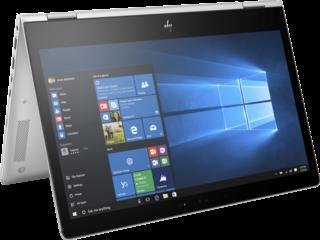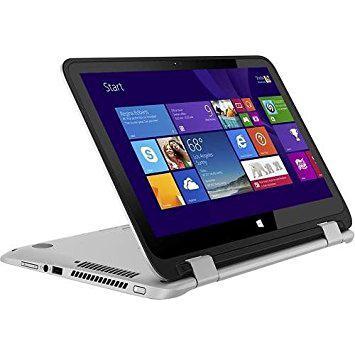The first image is the image on the left, the second image is the image on the right. Evaluate the accuracy of this statement regarding the images: "The open laptop on the left is displayed head-on, while the one on the right is turned at an angle.". Is it true? Answer yes or no. No. The first image is the image on the left, the second image is the image on the right. Analyze the images presented: Is the assertion "Every single laptop appears to be powered on right now." valid? Answer yes or no. Yes. 